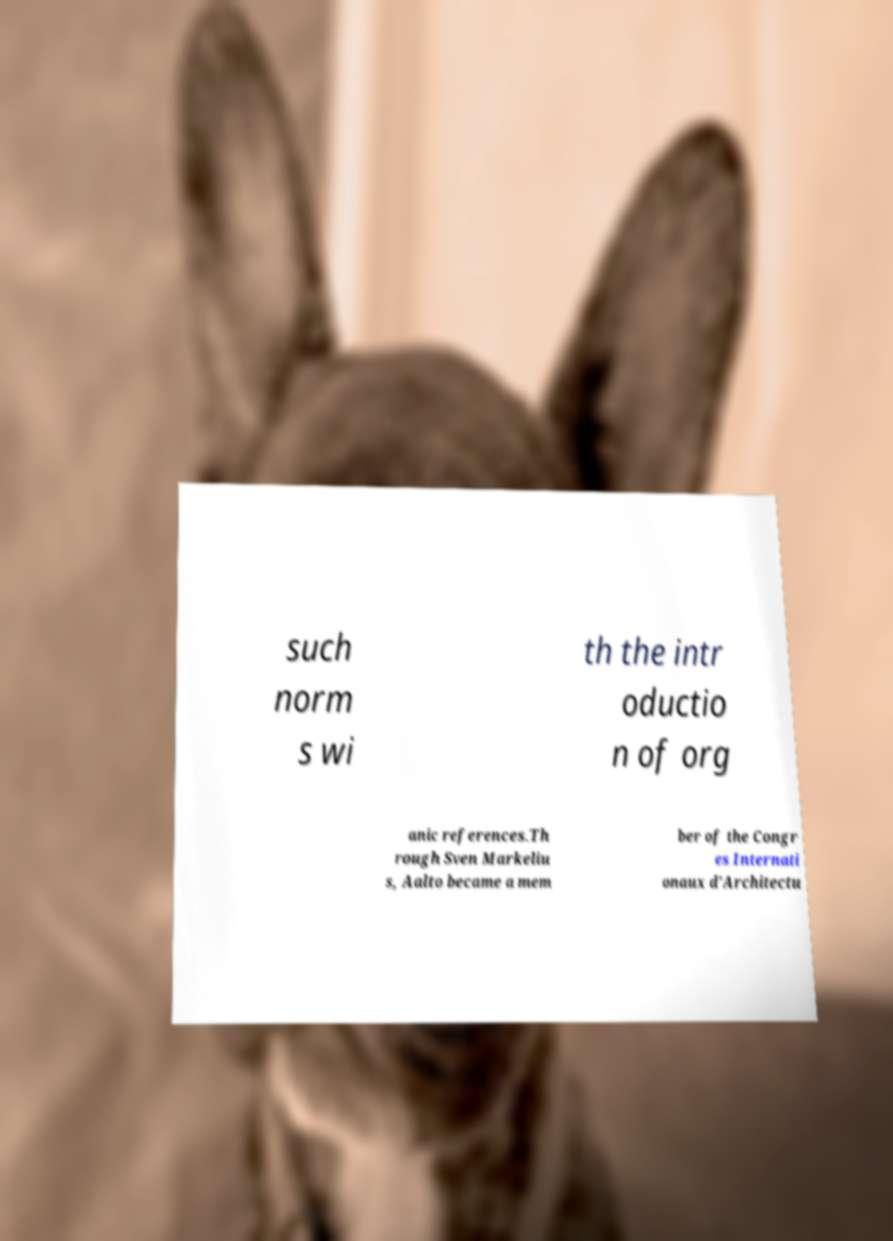I need the written content from this picture converted into text. Can you do that? such norm s wi th the intr oductio n of org anic references.Th rough Sven Markeliu s, Aalto became a mem ber of the Congr es Internati onaux d'Architectu 